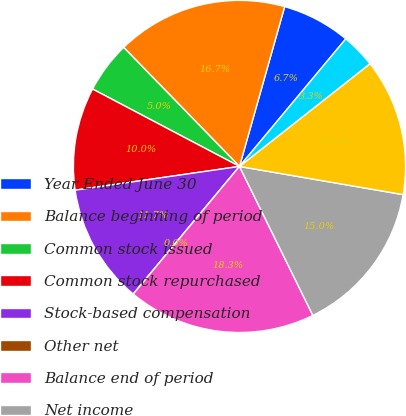Convert chart. <chart><loc_0><loc_0><loc_500><loc_500><pie_chart><fcel>Year Ended June 30<fcel>Balance beginning of period<fcel>Common stock issued<fcel>Common stock repurchased<fcel>Stock-based compensation<fcel>Other net<fcel>Balance end of period<fcel>Net income<fcel>Common stock cash dividends<fcel>Cumulative effect of<nl><fcel>6.67%<fcel>16.67%<fcel>5.0%<fcel>10.0%<fcel>11.67%<fcel>0.0%<fcel>18.33%<fcel>15.0%<fcel>13.33%<fcel>3.33%<nl></chart> 